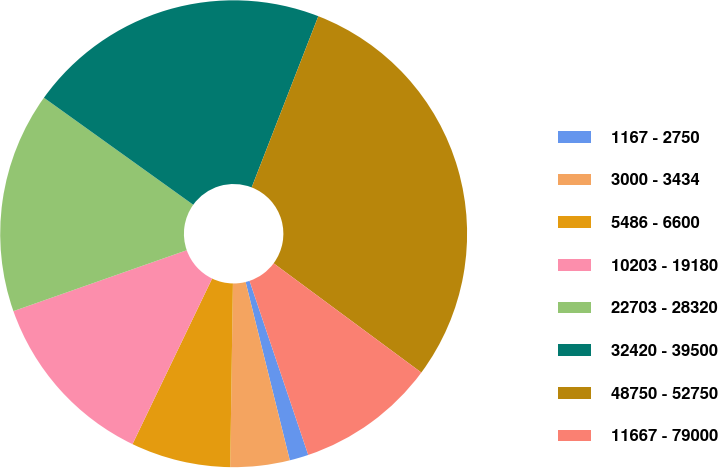Convert chart to OTSL. <chart><loc_0><loc_0><loc_500><loc_500><pie_chart><fcel>1167 - 2750<fcel>3000 - 3434<fcel>5486 - 6600<fcel>10203 - 19180<fcel>22703 - 28320<fcel>32420 - 39500<fcel>48750 - 52750<fcel>11667 - 79000<nl><fcel>1.31%<fcel>4.1%<fcel>6.9%<fcel>12.49%<fcel>15.28%<fcel>21.01%<fcel>29.23%<fcel>9.69%<nl></chart> 